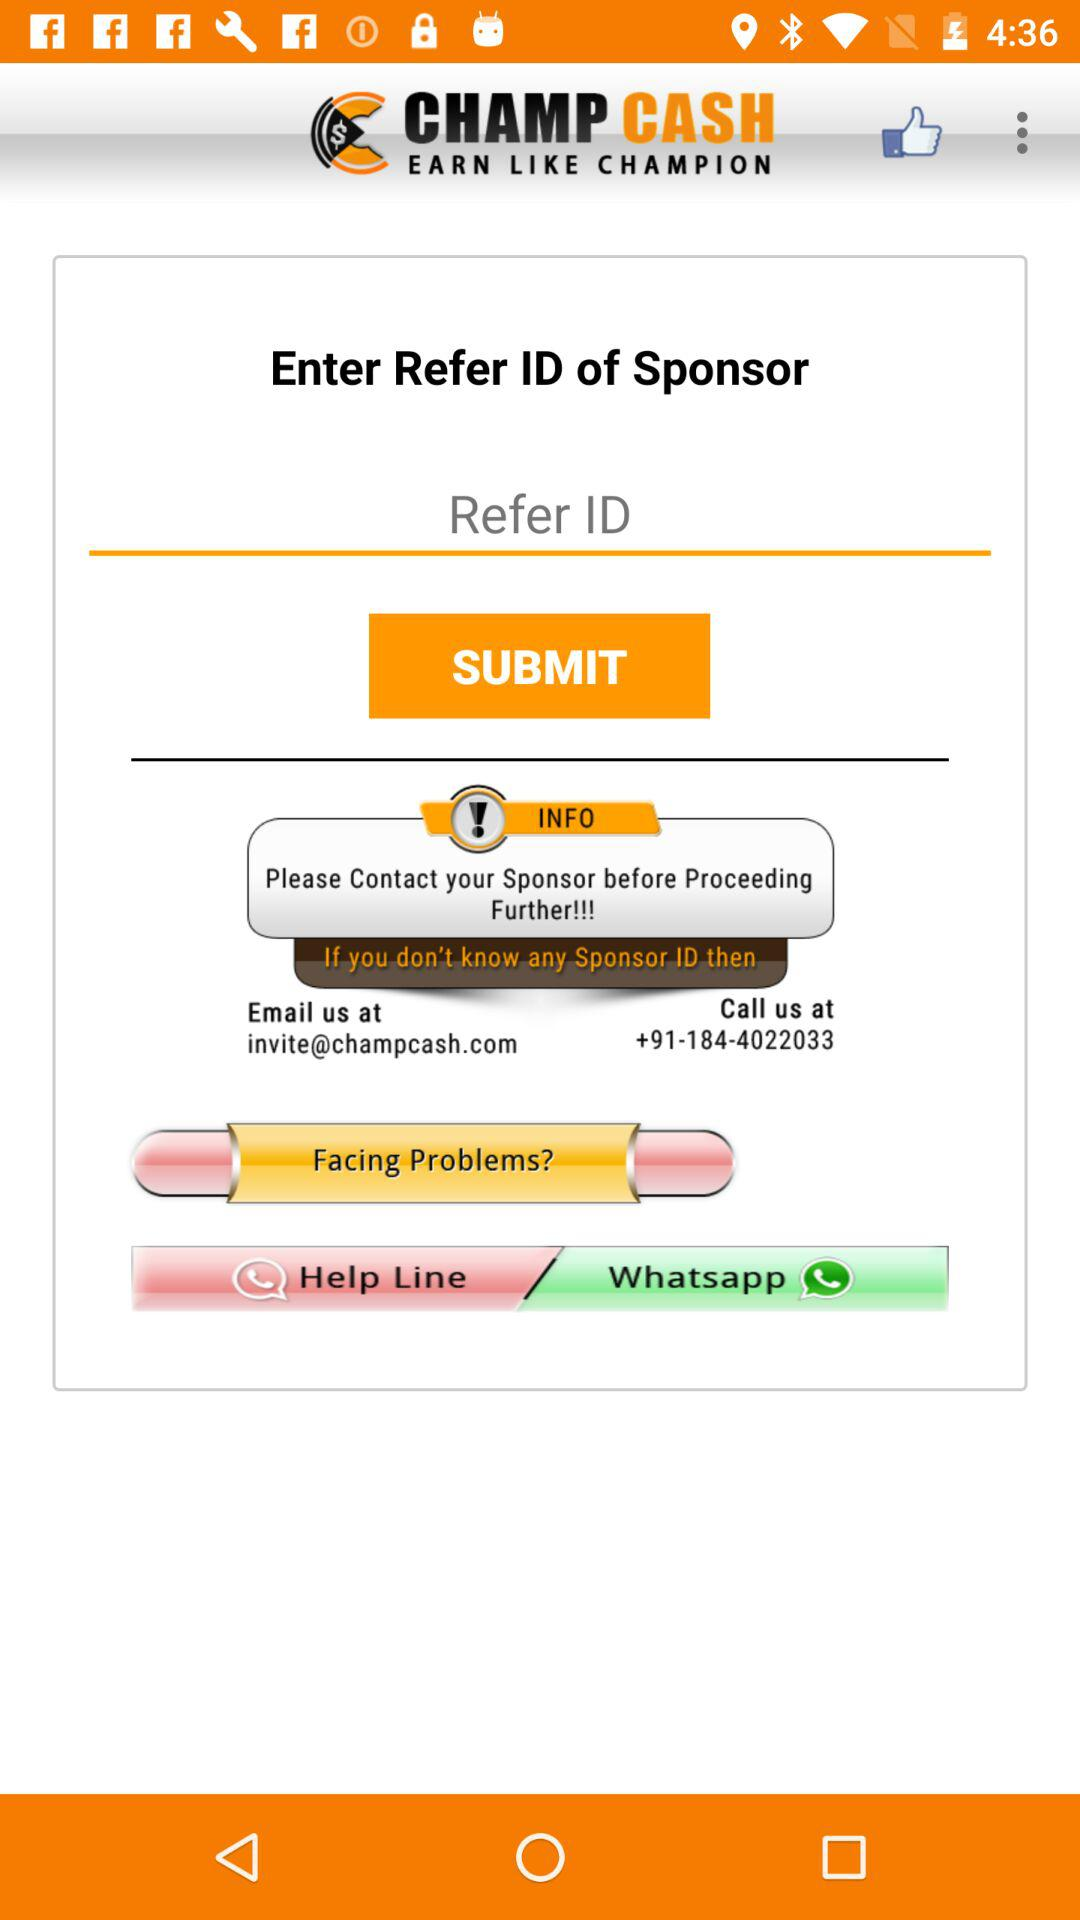What's the contact number? The contact number is +91-184-4022033. 